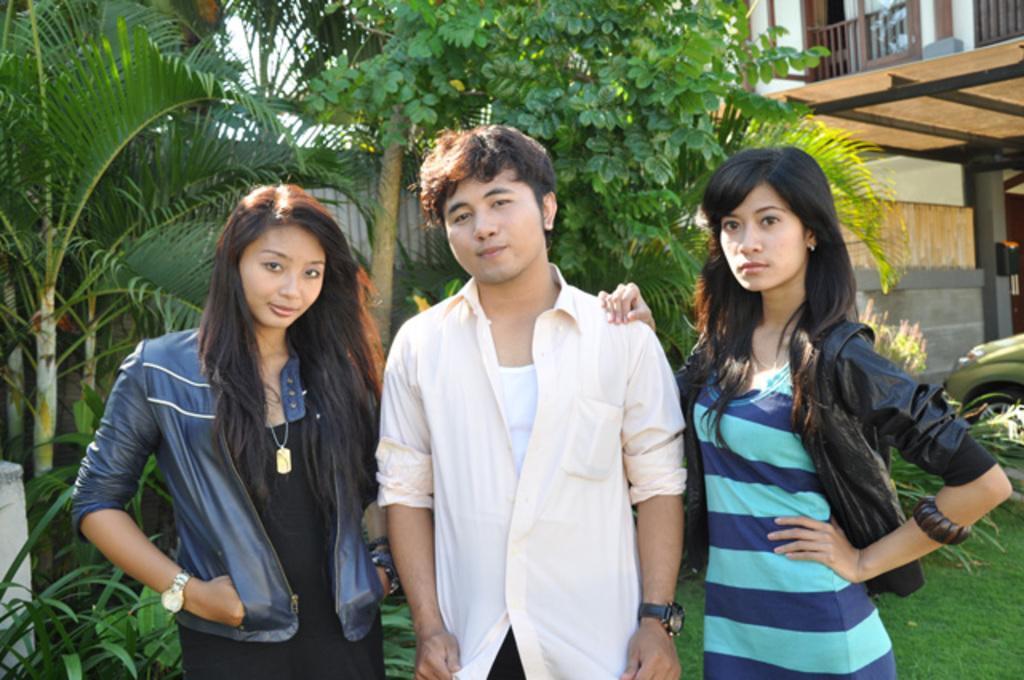Please provide a concise description of this image. In this image there is a man standing in between two women and posing for the camera, behind them there are trees and a building. 